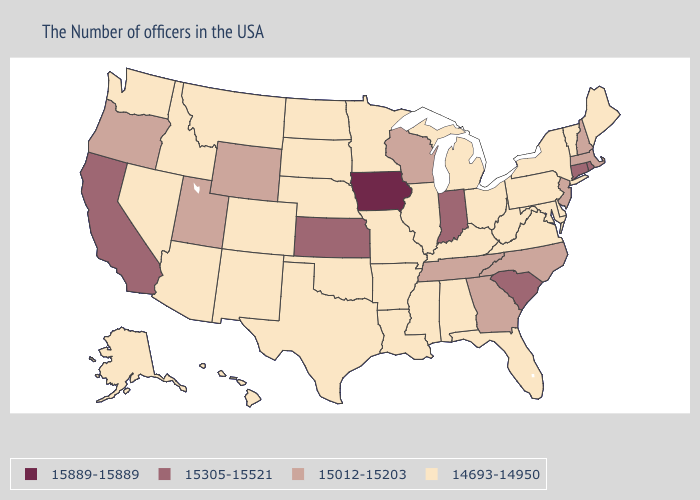What is the value of Iowa?
Be succinct. 15889-15889. What is the highest value in the Northeast ?
Quick response, please. 15305-15521. What is the highest value in the MidWest ?
Quick response, please. 15889-15889. What is the lowest value in the USA?
Short answer required. 14693-14950. Name the states that have a value in the range 15889-15889?
Short answer required. Iowa. What is the lowest value in states that border South Carolina?
Be succinct. 15012-15203. Name the states that have a value in the range 15305-15521?
Quick response, please. Rhode Island, Connecticut, South Carolina, Indiana, Kansas, California. What is the value of Indiana?
Answer briefly. 15305-15521. Among the states that border North Dakota , which have the lowest value?
Be succinct. Minnesota, South Dakota, Montana. Name the states that have a value in the range 15889-15889?
Give a very brief answer. Iowa. Does New Jersey have a higher value than Maine?
Concise answer only. Yes. Does Florida have a lower value than Minnesota?
Give a very brief answer. No. What is the lowest value in states that border South Carolina?
Be succinct. 15012-15203. Name the states that have a value in the range 15889-15889?
Give a very brief answer. Iowa. Is the legend a continuous bar?
Answer briefly. No. 